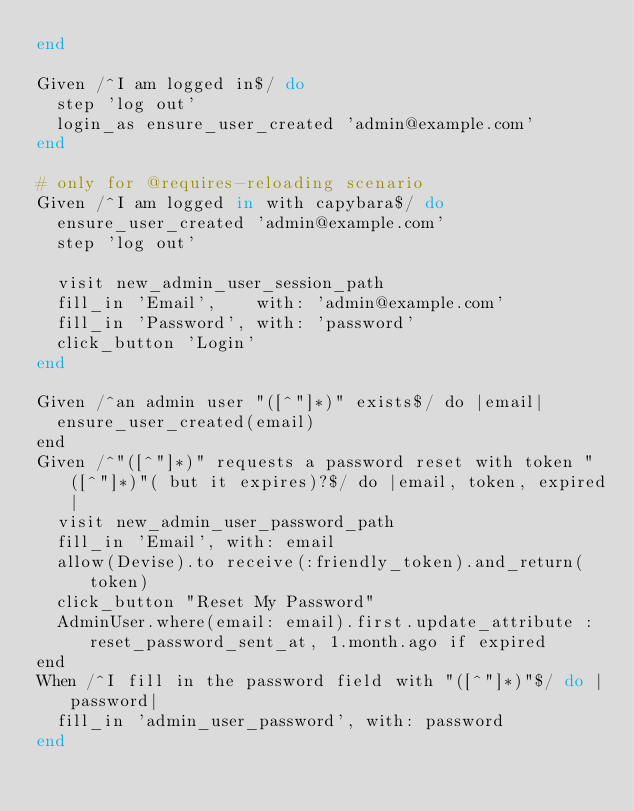Convert code to text. <code><loc_0><loc_0><loc_500><loc_500><_Ruby_>end

Given /^I am logged in$/ do
  step 'log out'
  login_as ensure_user_created 'admin@example.com'
end

# only for @requires-reloading scenario
Given /^I am logged in with capybara$/ do
  ensure_user_created 'admin@example.com'
  step 'log out'

  visit new_admin_user_session_path
  fill_in 'Email',    with: 'admin@example.com'
  fill_in 'Password', with: 'password'
  click_button 'Login'
end

Given /^an admin user "([^"]*)" exists$/ do |email|
  ensure_user_created(email)
end
Given /^"([^"]*)" requests a password reset with token "([^"]*)"( but it expires)?$/ do |email, token, expired|
  visit new_admin_user_password_path
  fill_in 'Email', with: email
  allow(Devise).to receive(:friendly_token).and_return(token)
  click_button "Reset My Password"
  AdminUser.where(email: email).first.update_attribute :reset_password_sent_at, 1.month.ago if expired
end
When /^I fill in the password field with "([^"]*)"$/ do |password|
  fill_in 'admin_user_password', with: password
end

</code> 